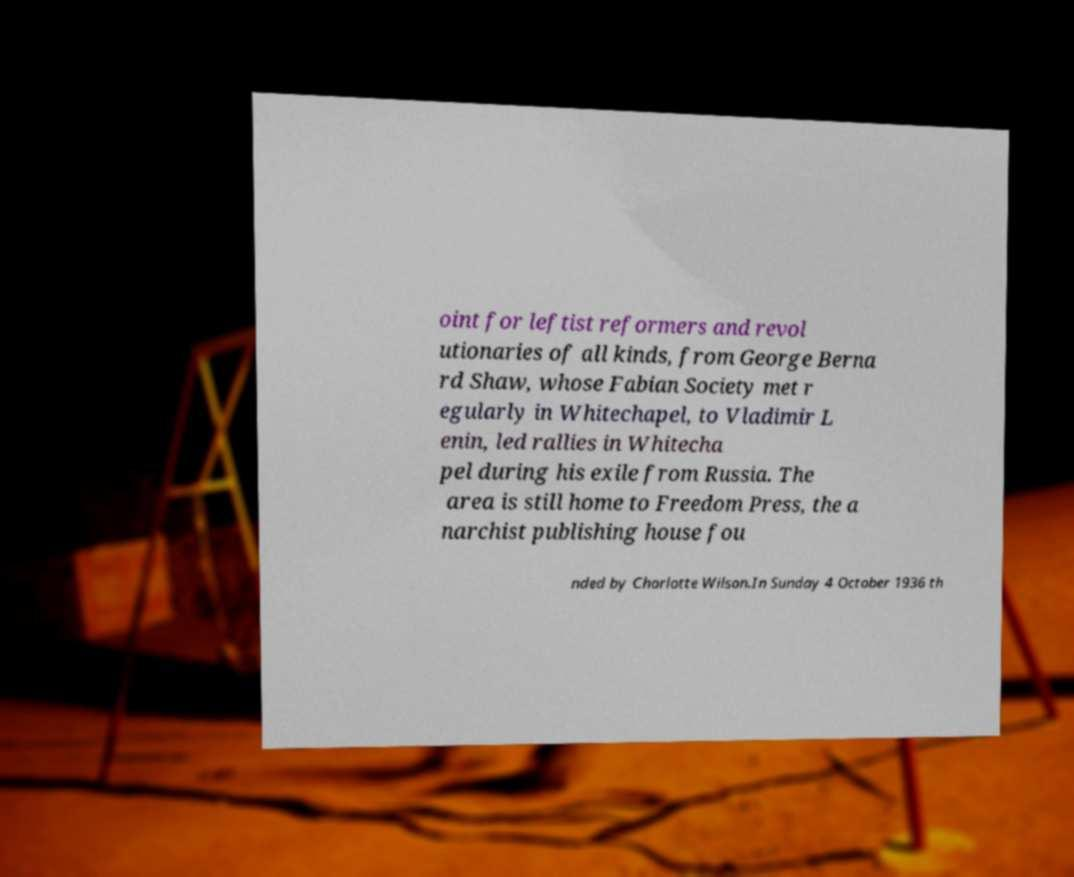Please identify and transcribe the text found in this image. oint for leftist reformers and revol utionaries of all kinds, from George Berna rd Shaw, whose Fabian Society met r egularly in Whitechapel, to Vladimir L enin, led rallies in Whitecha pel during his exile from Russia. The area is still home to Freedom Press, the a narchist publishing house fou nded by Charlotte Wilson.In Sunday 4 October 1936 th 